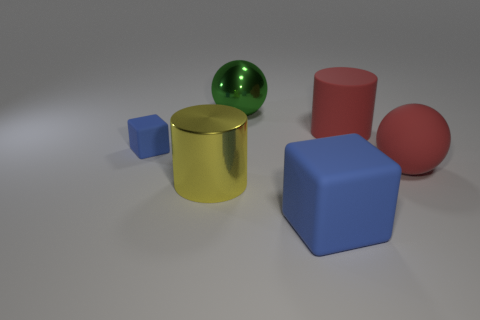Add 2 large rubber spheres. How many objects exist? 8 Subtract all cylinders. How many objects are left? 4 Add 2 yellow metal spheres. How many yellow metal spheres exist? 2 Subtract 1 red spheres. How many objects are left? 5 Subtract all yellow metallic objects. Subtract all large matte cubes. How many objects are left? 4 Add 4 big red cylinders. How many big red cylinders are left? 5 